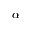<formula> <loc_0><loc_0><loc_500><loc_500>\alpha</formula> 